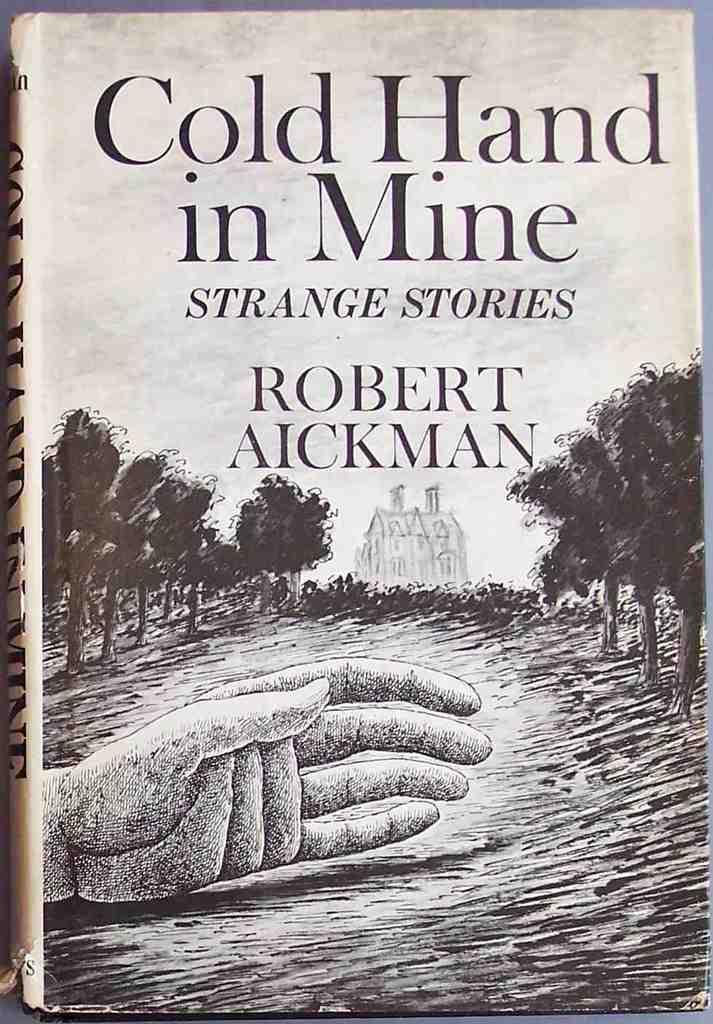Who is the author of the book?
Your response must be concise. Robert aickman. What is the books title?
Make the answer very short. Cold hand in mine. 